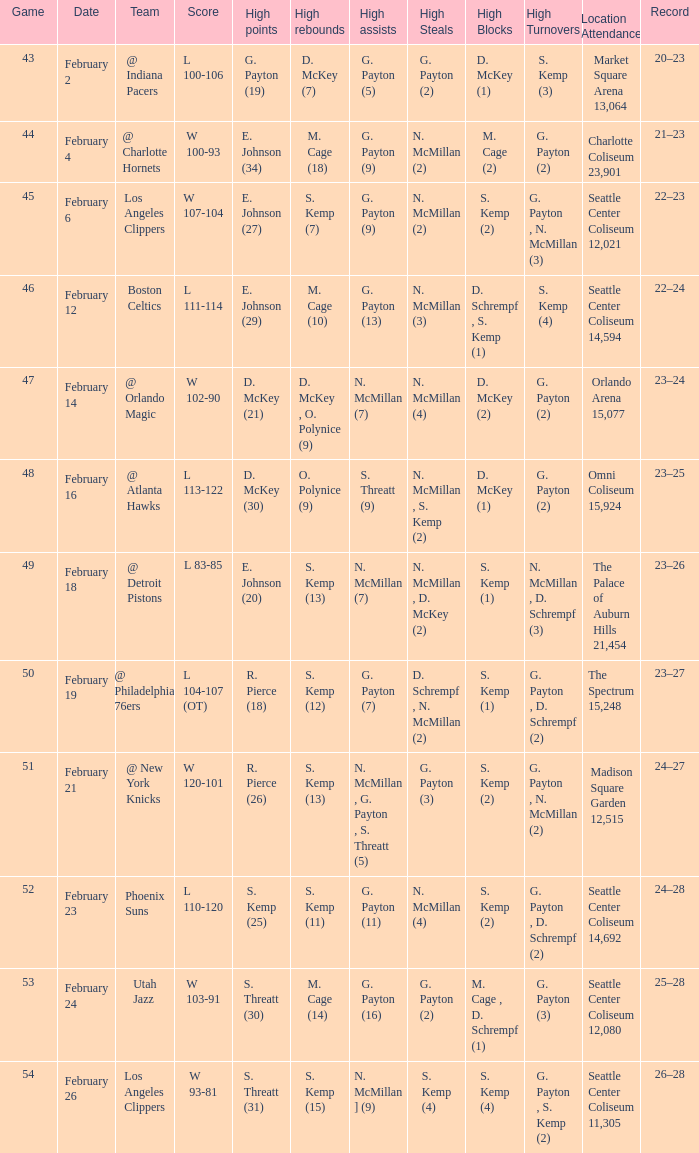What is the record for the Utah Jazz? 25–28. 